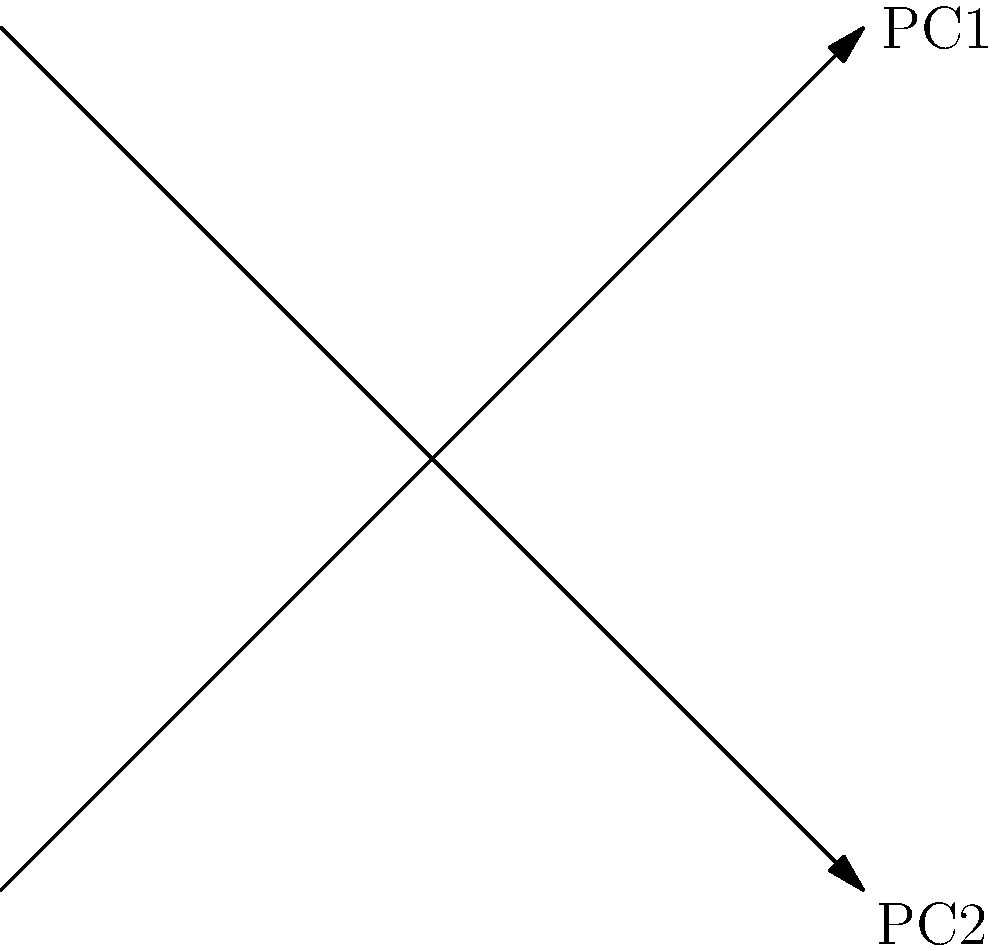Based on the PCA biplot shown above, which feature (F1-F7) appears to have the strongest positive correlation with the first principal component (PC1), and how does this information help in feature selection for predictive modeling? To answer this question, we need to analyze the PCA biplot step-by-step:

1. Understand the biplot: The plot shows both the data points (labeled F1-F7) and the principal component loadings (red arrows V1 and V2).

2. Identify PC1: The first principal component (PC1) is typically represented by the x-axis in a biplot. In this case, it's the diagonal line from bottom-left to top-right.

3. Analyze feature positions: Look at the positions of the features (F1-F7) relative to PC1.

4. Identify the feature with strongest positive correlation: The feature that is furthest along PC1 in the positive direction (top-right) will have the strongest positive correlation with PC1. In this case, it's F5.

5. Interpret for feature selection: Features strongly correlated with PC1 explain the most variance in the dataset. This means:
   a) F5 likely contains important information for the predictive model.
   b) F5 might be a good candidate for feature selection if we need to reduce dimensionality.
   c) However, we should also consider other factors like domain knowledge and the specific problem we're trying to solve.

6. Consider other features: While F5 has the strongest positive correlation, F4 and F7 also show positive correlations with PC1, suggesting they might be important features as well.

7. Look at opposing features: F1 and F2 are on the opposite end of PC1, indicating strong negative correlations. These might also be important features, just in the opposite direction.

This analysis helps in feature selection by identifying which features capture the most variance in the data, potentially leading to more efficient and effective predictive models.
Answer: F5; it explains most variance, suggesting importance for the model, but consider other factors for final selection. 